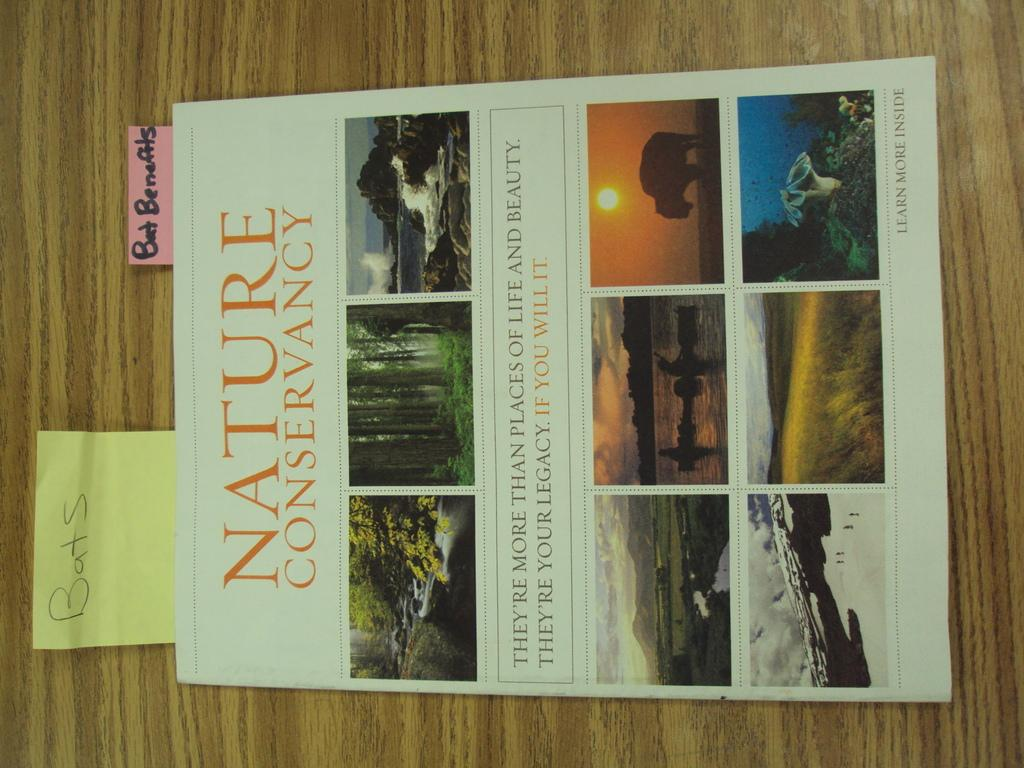<image>
Give a short and clear explanation of the subsequent image. A flyer for nature conservancy with a sticky note attached saying bats. 